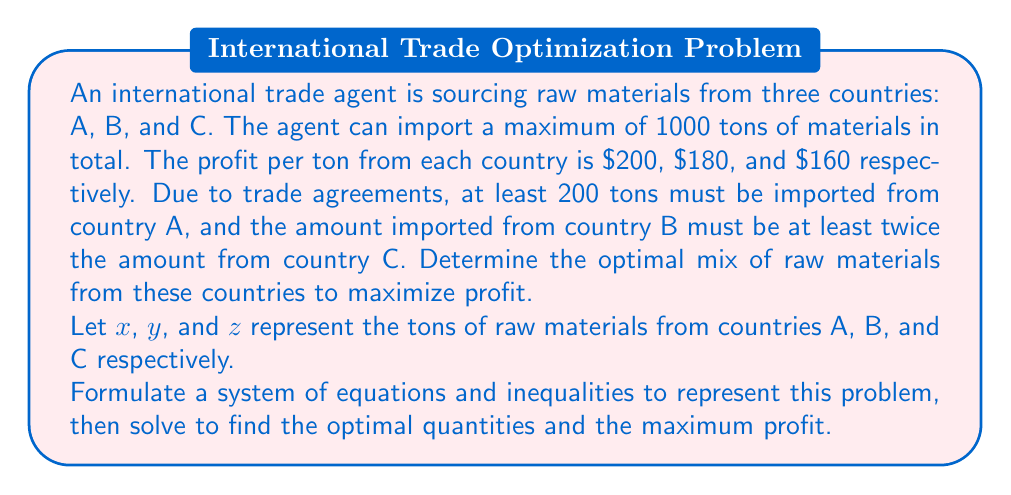Help me with this question. Let's approach this step-by-step:

1) First, we need to set up our objective function and constraints:

   Objective function (to maximize): $P = 200x + 180y + 160z$

   Constraints:
   - Total amount: $x + y + z \leq 1000$
   - Minimum from A: $x \geq 200$
   - B at least twice C: $y \geq 2z$
   - Non-negativity: $x, y, z \geq 0$

2) We want to maximize profit, so we should use as much of the 1000 ton capacity as possible. This turns the first inequality into an equation:

   $x + y + z = 1000$

3) To maximize profit, we should use as much as possible from the higher-profit countries. So, we'll use the minimum required from A, then allocate the rest between B and C.

   $x = 200$

4) Substituting this into the total amount equation:

   $200 + y + z = 1000$
   $y + z = 800$

5) We know that $y \geq 2z$. To maximize profit, we should make this an equality:

   $y = 2z$

6) Substituting this into the equation from step 4:

   $2z + z = 800$
   $3z = 800$
   $z = 800/3 \approx 266.67$

7) Since we can't import fractional tons, we round down:

   $z = 266$
   $y = 2z = 532$
   $x = 200$ (as determined earlier)

8) We can verify: $200 + 532 + 266 = 998$ (which is less than 1000, satisfying our constraint)

9) Calculate the maximum profit:

   $P = 200(200) + 180(532) + 160(266) = 40,000 + 95,760 + 42,560 = 178,320$
Answer: The optimal mix is 200 tons from country A, 532 tons from country B, and 266 tons from country C. The maximum profit is $178,320. 